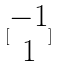<formula> <loc_0><loc_0><loc_500><loc_500>[ \begin{matrix} - 1 \\ 1 \end{matrix} ]</formula> 